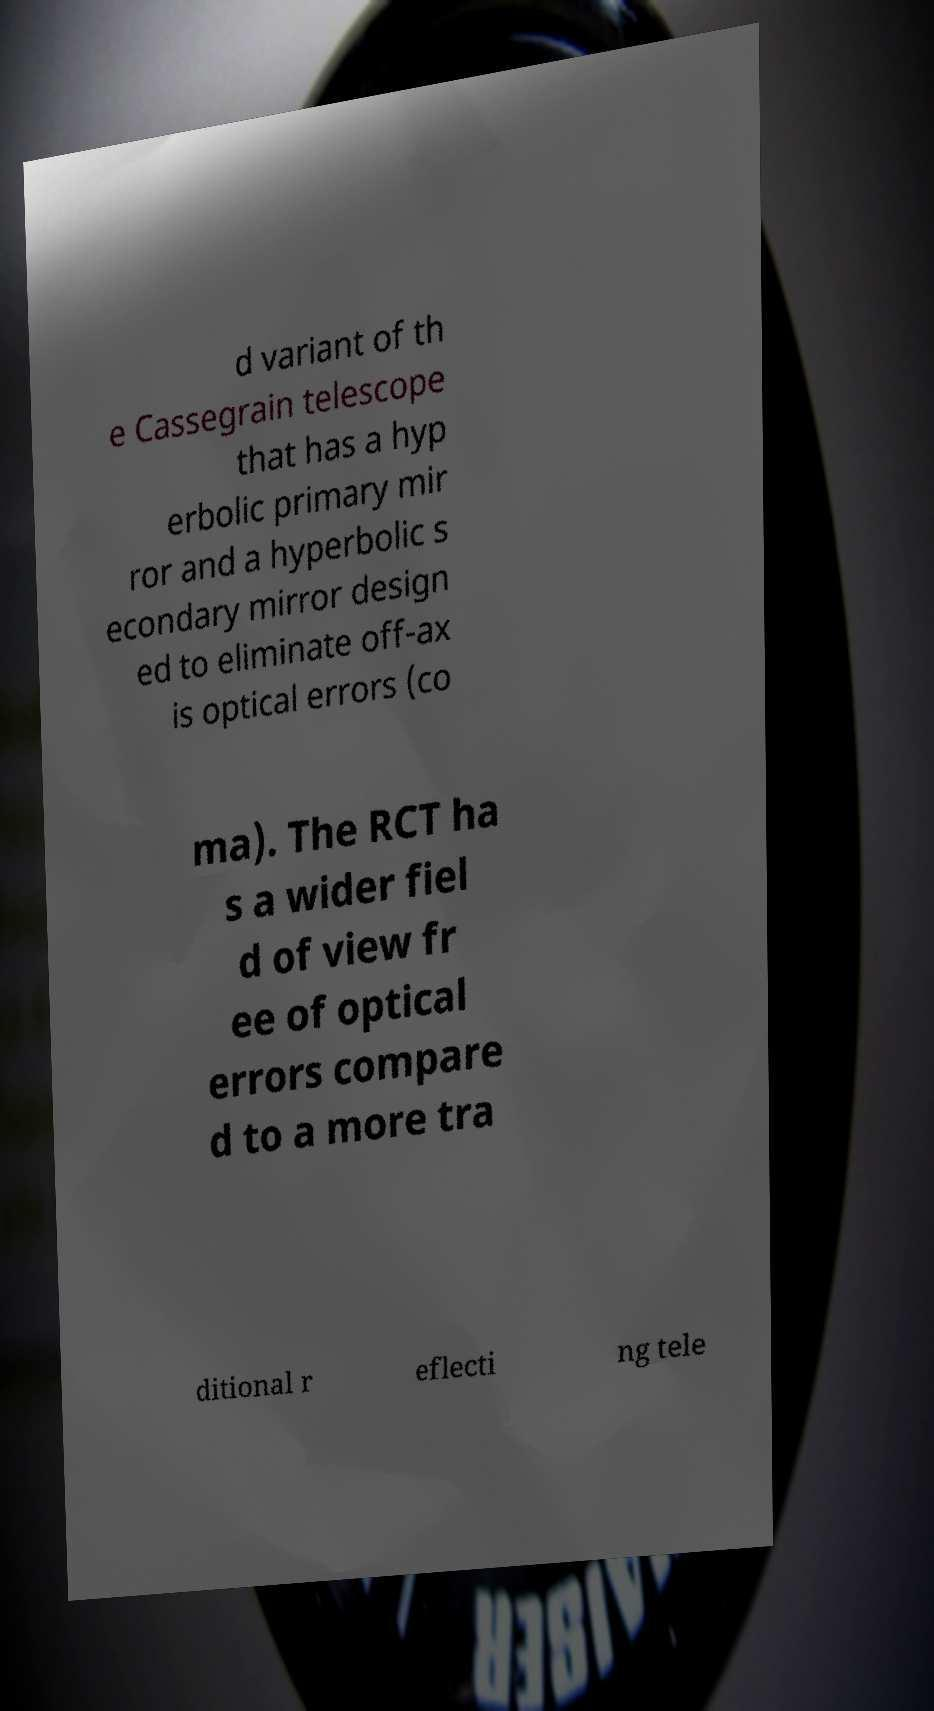What messages or text are displayed in this image? I need them in a readable, typed format. d variant of th e Cassegrain telescope that has a hyp erbolic primary mir ror and a hyperbolic s econdary mirror design ed to eliminate off-ax is optical errors (co ma). The RCT ha s a wider fiel d of view fr ee of optical errors compare d to a more tra ditional r eflecti ng tele 